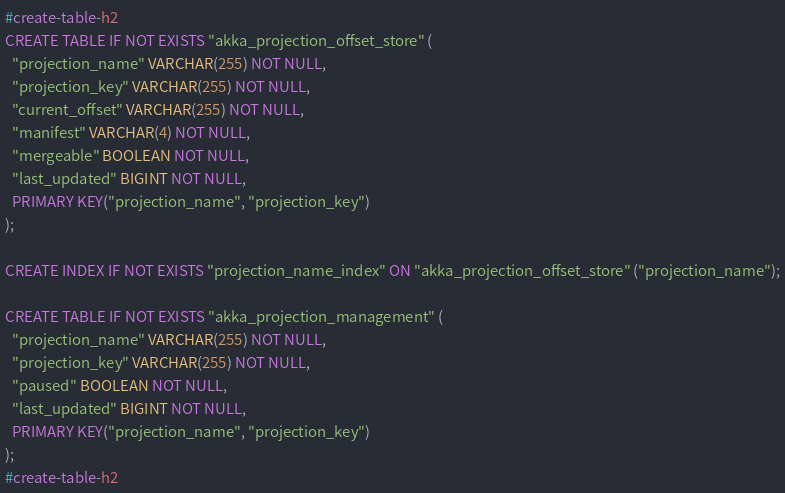<code> <loc_0><loc_0><loc_500><loc_500><_SQL_>
#create-table-h2
CREATE TABLE IF NOT EXISTS "akka_projection_offset_store" (
  "projection_name" VARCHAR(255) NOT NULL,
  "projection_key" VARCHAR(255) NOT NULL,
  "current_offset" VARCHAR(255) NOT NULL,
  "manifest" VARCHAR(4) NOT NULL,
  "mergeable" BOOLEAN NOT NULL,
  "last_updated" BIGINT NOT NULL,
  PRIMARY KEY("projection_name", "projection_key")
);

CREATE INDEX IF NOT EXISTS "projection_name_index" ON "akka_projection_offset_store" ("projection_name");

CREATE TABLE IF NOT EXISTS "akka_projection_management" (
  "projection_name" VARCHAR(255) NOT NULL,
  "projection_key" VARCHAR(255) NOT NULL,
  "paused" BOOLEAN NOT NULL,
  "last_updated" BIGINT NOT NULL,
  PRIMARY KEY("projection_name", "projection_key")
);
#create-table-h2
</code> 